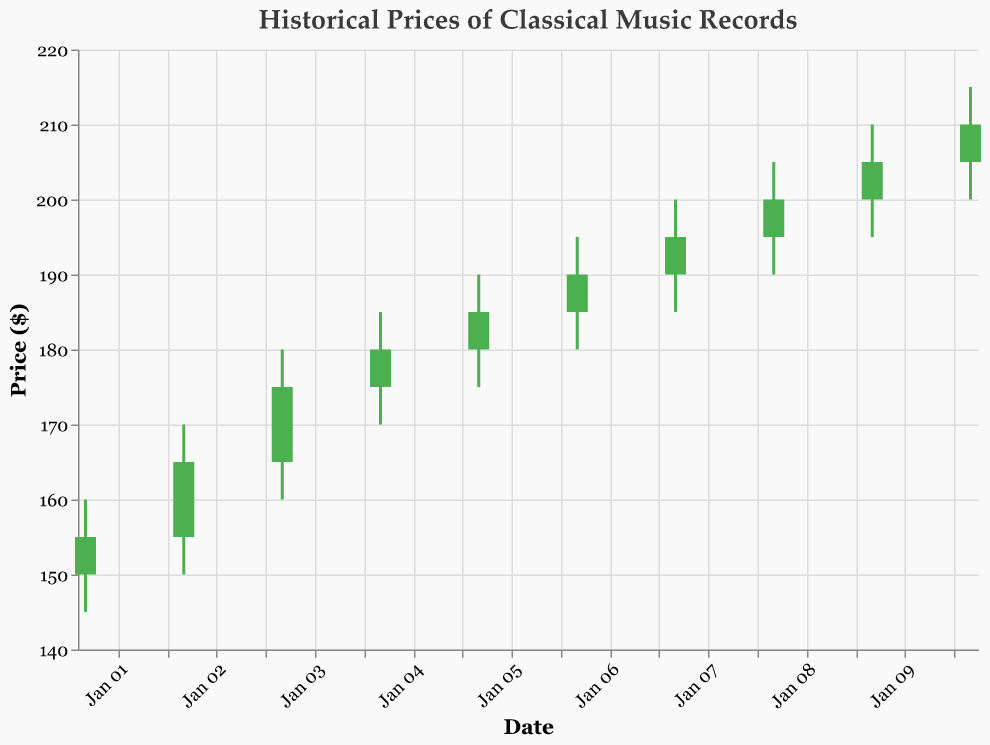What is the title of the plot? The plot title is usually displayed at the top of the graph in a larger and bold font. Here the title is 'Historical Prices of Classical Music Records'.
Answer: Historical Prices of Classical Music Records How many days are represented in this plot? There's one data point for each day, represented on the X-axis. Counting the number of days from January 1st to January 10th shows there are 10 days in total.
Answer: 10 On which date did the closing price first reach $200? By looking at the closing prices (represented by the top or bottom of the candlestick bar) we see that on January 8th, the closing price first reached $200.
Answer: January 8th Which day had the highest trading volume? The trading volume can be identified from the data. The date with the highest volume is January 9th with 400 units.
Answer: January 9th What is the difference between the highest and lowest prices on January 4th? For January 4th, the highest price is $185 and the lowest price is $170. Subtracting these gives $185 - $170 = $15.
Answer: $15 On which day did the opening price equal the closing price? Comparing the open and close prices for each date, we see they are equal on January 10th ($205).
Answer: January 10th What was the average closing price over the 10-day period? Adding all the closing prices and dividing by the number of days (155 + 165 + 175 + 180 + 185 + 190 + 195 + 200 + 205 + 210) / 10 = 1860 / 10 = $186.
Answer: $186 Which day had the smallest range between the high and low price? To find the smallest range, calculate the difference between the high and low prices for each day. January 4th has the smallest range with $185 - $170 = $15.
Answer: January 4th Did the price trend upwards or downwards over the 10 days? By observing the overall direction from the first day's close ($155) to the last day's close ($210), we can see a clear upward trend.
Answer: Upwards What were the highest and lowest prices recorded in this period? Scanning through the data, the highest price recorded was $215 on January 10th, and the lowest price was $145 on January 1st.
Answer: Highest: $215, Lowest: $145 